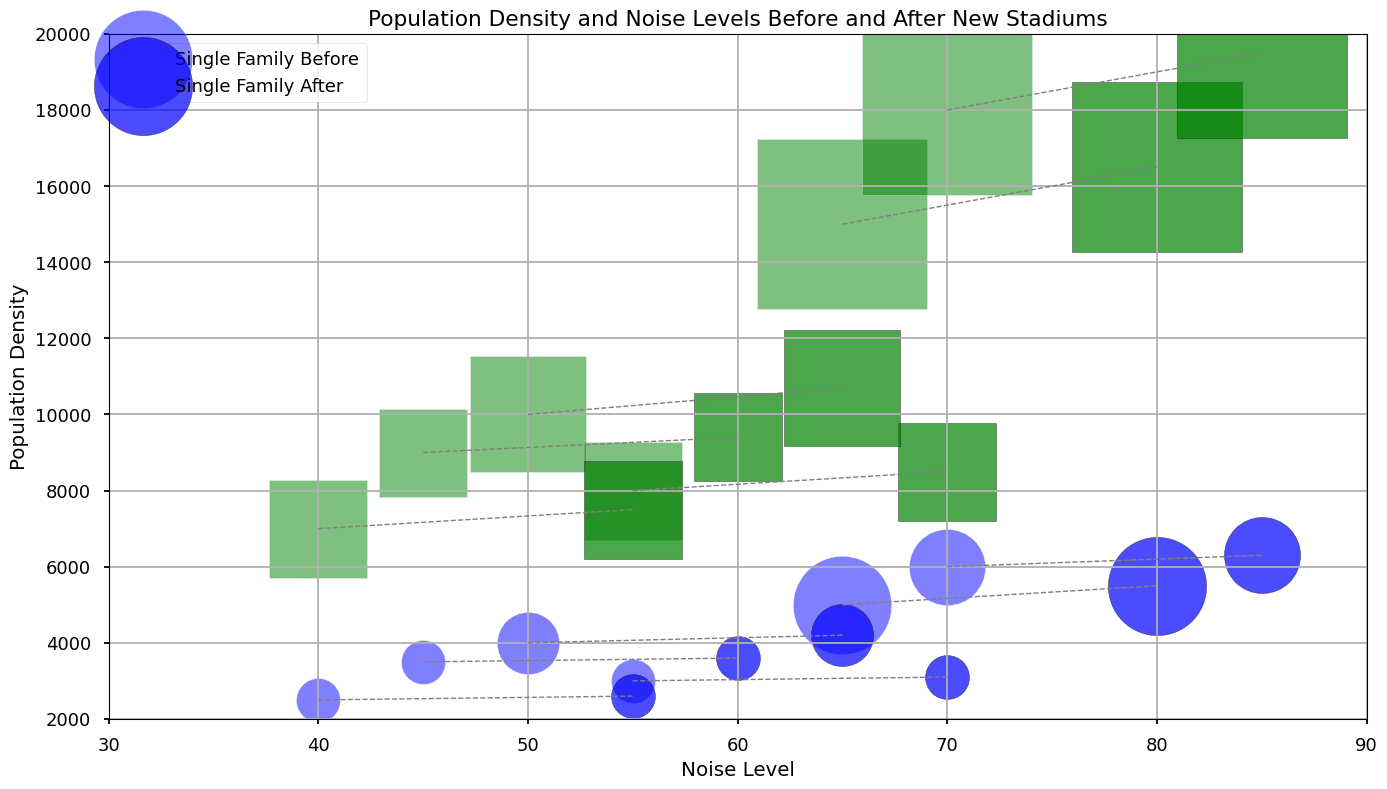Do population densities change more for Single Family homes or Apartments? Compare the bubbles labeled “Before” and “After” for both Single Family and Apartments across all neighborhoods. Identify which type of housing shows larger changes in bubble sizes, which indicate changes in population density.
Answer: Apartments In which neighborhood does noise level increase the most? Look at the horizontal movement from "Before" to "After" across neighborhoods and identify which has the largest increase on the noise level axis.
Answer: Uptown Which neighborhood shows the smallest change in population density for Single Family homes? Compare the vertical distance between "Before" and "After" for Single Family homes across all neighborhoods. Identify which neighborhood shows the smallest vertical change.
Answer: Lakeside Is there a neighborhood where Apartments have a larger increase in population density than Single Family homes? Compare the vertical distances between "Before" and "After" for Apartments and Single Family homes within each neighborhood. Check if any neighborhood has a larger increase for Apartments.
Answer: Yes, all neighborhoods Which neighborhood is the most affected by increases in both population density and noise level for Apartments? Identify the neighborhood where the "After" bubbles for Apartments show the greatest vertical (population density) and horizontal (noise level) distances from the "Before" bubbles.
Answer: Uptown 